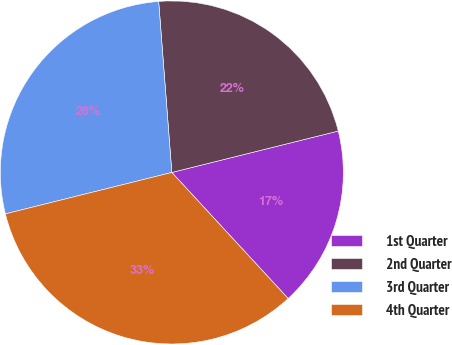Convert chart to OTSL. <chart><loc_0><loc_0><loc_500><loc_500><pie_chart><fcel>1st Quarter<fcel>2nd Quarter<fcel>3rd Quarter<fcel>4th Quarter<nl><fcel>17.02%<fcel>22.34%<fcel>27.66%<fcel>32.98%<nl></chart> 